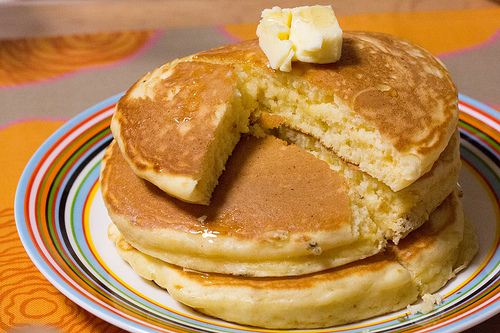<image>
Is there a pancake under the butter? Yes. The pancake is positioned underneath the butter, with the butter above it in the vertical space. 